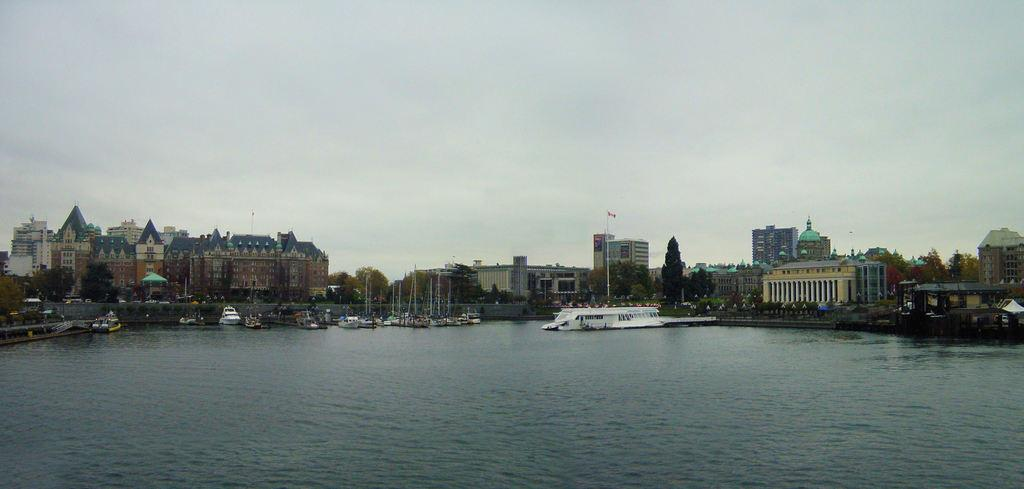What is located in the middle of the image? In the middle of the image, there are boats, poles, buildings, trees, a flag, and tents. Can you describe the natural elements in the image? The sky is visible in the image, with clouds present. There are also waves and water visible at the bottom of the image. What type of structures can be seen in the image? The image features buildings and tents. What type of amusement can be seen in the image? There is no amusement present in the image. --- Facts: 1. There is a person in the image. 12. The person is wearing a hat. 13. The person is holding a book. 14. The person is standing on a wooden platform. 15. There is a wooden fence in the background. Conversation: What is the person in the image doing? The person in the image is standing on a wooden platform and holding a book. Can you describe the person's attire in the image? The person in the image is wearing a hat. What type of structure can be seen in the background? There is a wooden fence in the background. How many wooden structures can be seen in the image? There is one wooden structure visible in the image, which is the wooden fence in the background. Reasoning: Let's think step by step in order to produce the conversation. We start by identifying the main subject in the image, which is the person. Then, we describe the person's actions and attire, noting that they are standing on a wooden platform and holding a book. Next, we observe the background, noting the presence of a wooden fence. Finally, we count the number of wooden structures visible in the image, which is one wooden fence. Absurd Question/Answer: What type of food is the person in the image eating? There is no food present in the image. 